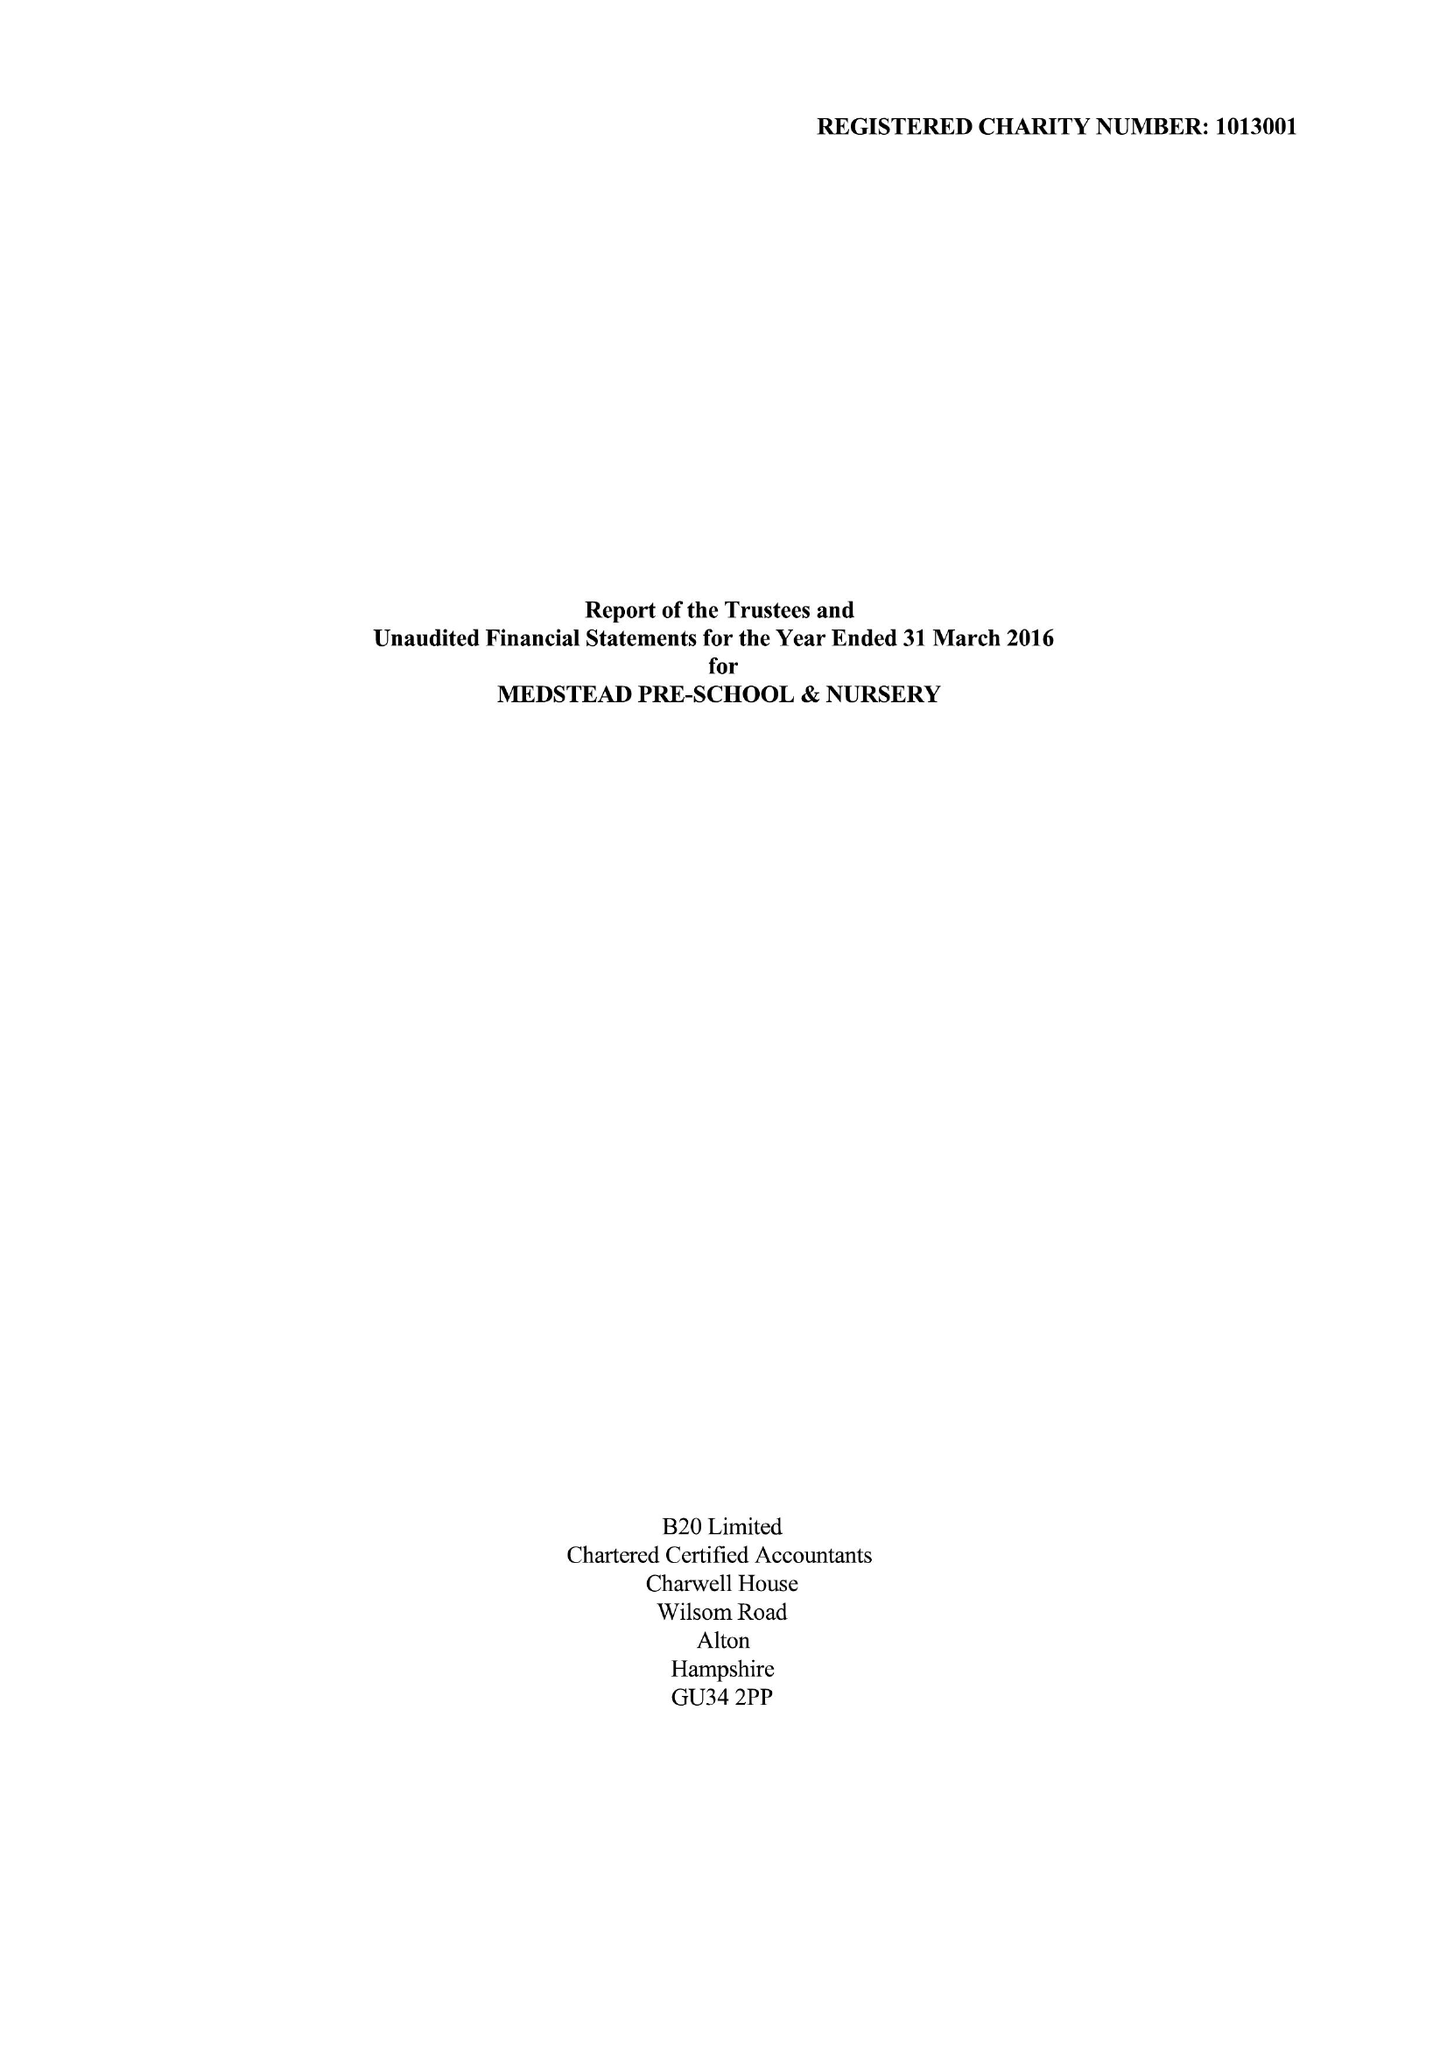What is the value for the charity_number?
Answer the question using a single word or phrase. 1013001 